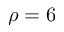<formula> <loc_0><loc_0><loc_500><loc_500>\rho = 6</formula> 